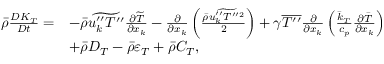<formula> <loc_0><loc_0><loc_500><loc_500>\begin{array} { r l } { \bar { \rho } \frac { D K _ { T } } { D t } = } & { - \bar { \rho } \widetilde { u _ { k } ^ { \prime \prime } T ^ { \prime \prime } } \frac { \partial \widetilde { T } } { \partial x _ { k } } - \frac { \partial } { \partial x _ { k } } \left ( \frac { \bar { \rho } \widetilde { u _ { k } ^ { \prime \prime } T ^ { \prime \prime 2 } } } { 2 } \right ) + \gamma \overline { { T ^ { \prime \prime } } } \frac { \partial } { \partial x _ { k } } \left ( \frac { \bar { k } _ { T } } { c _ { p } } \frac { \partial \bar { T } } { \partial x _ { k } } \right ) } \\ & { + \bar { \rho } D _ { T } - \bar { \rho } \varepsilon _ { T } + \bar { \rho } C _ { T } , } \end{array}</formula> 